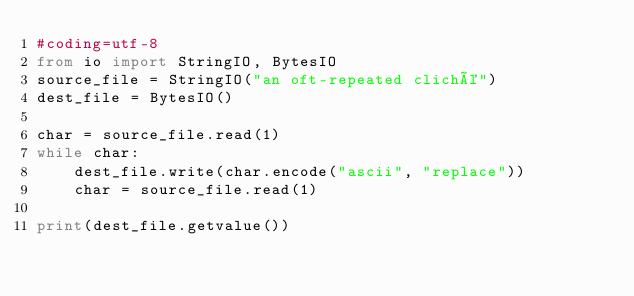<code> <loc_0><loc_0><loc_500><loc_500><_Python_>#coding=utf-8
from io import StringIO, BytesIO
source_file = StringIO("an oft-repeated cliché")
dest_file = BytesIO()

char = source_file.read(1)
while char:
    dest_file.write(char.encode("ascii", "replace"))
    char = source_file.read(1)

print(dest_file.getvalue())

</code> 